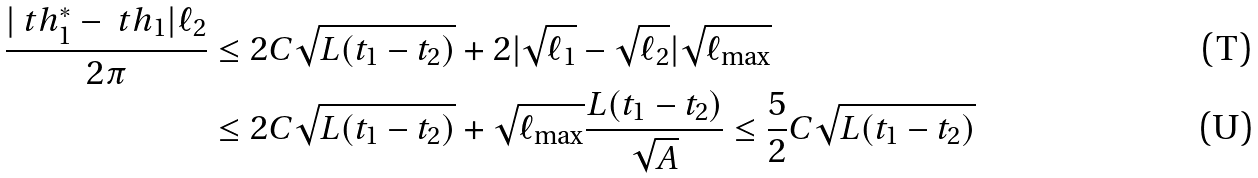Convert formula to latex. <formula><loc_0><loc_0><loc_500><loc_500>\frac { | \ t h _ { 1 } ^ { * } - \ t h _ { 1 } | \ell _ { 2 } } { 2 \pi } & \leq 2 C \sqrt { L ( t _ { 1 } - t _ { 2 } ) } + 2 | \sqrt { \ell _ { 1 } } - \sqrt { \ell _ { 2 } } | \sqrt { \ell _ { \max } } \\ & \leq 2 C \sqrt { L ( t _ { 1 } - t _ { 2 } ) } + \sqrt { \ell _ { \max } } \frac { L ( t _ { 1 } - t _ { 2 } ) } { \sqrt { A } } \leq \frac { 5 } { 2 } C \sqrt { L ( t _ { 1 } - t _ { 2 } ) }</formula> 